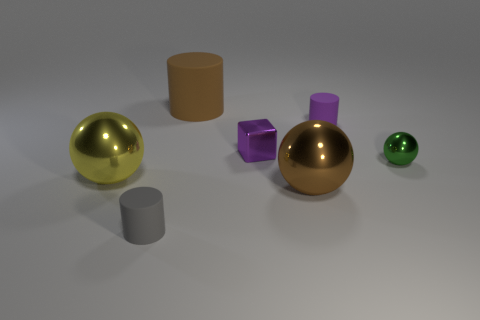Add 2 big shiny balls. How many objects exist? 9 Subtract all balls. How many objects are left? 4 Add 7 small purple rubber cylinders. How many small purple rubber cylinders are left? 8 Add 3 small purple rubber things. How many small purple rubber things exist? 4 Subtract 0 red spheres. How many objects are left? 7 Subtract all large brown cubes. Subtract all tiny purple metal blocks. How many objects are left? 6 